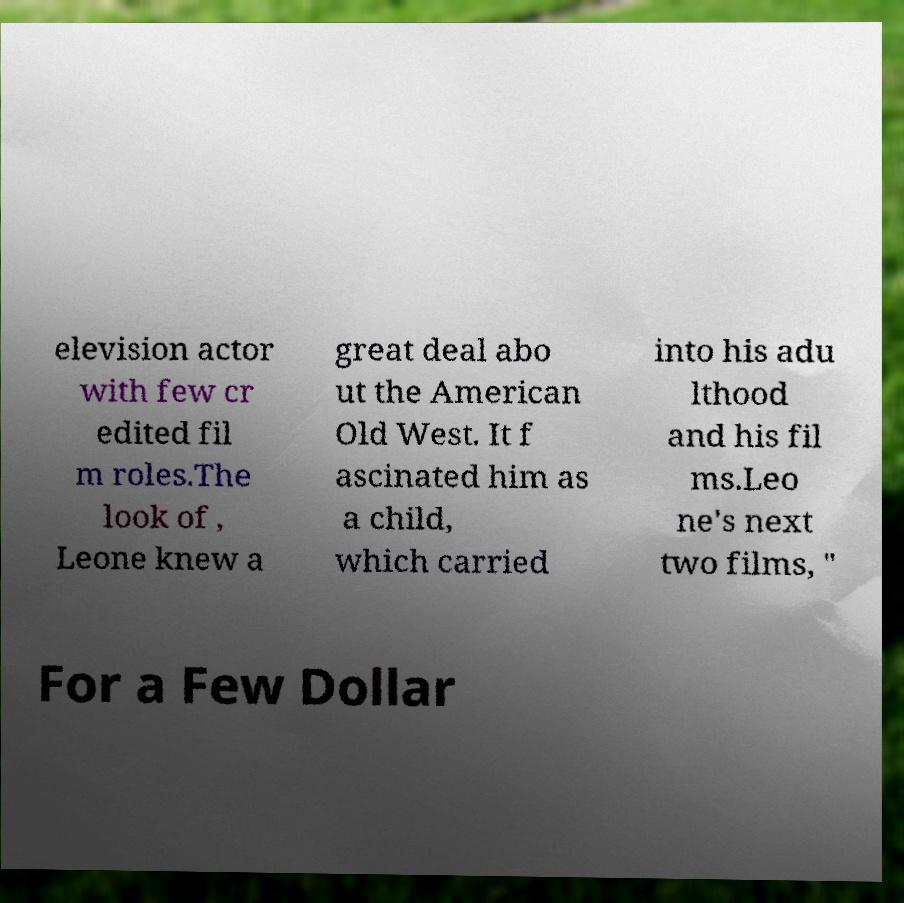Can you accurately transcribe the text from the provided image for me? elevision actor with few cr edited fil m roles.The look of , Leone knew a great deal abo ut the American Old West. It f ascinated him as a child, which carried into his adu lthood and his fil ms.Leo ne's next two films, " For a Few Dollar 